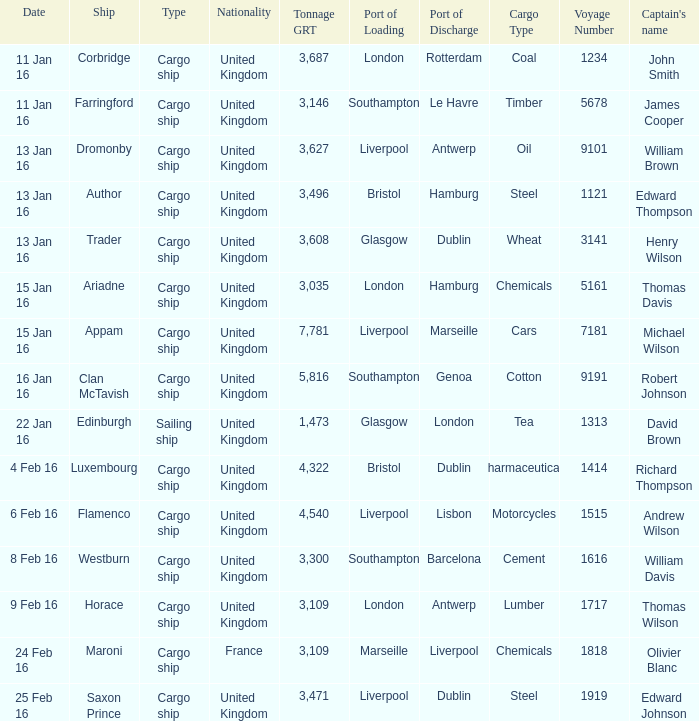What is the total tonnage grt of the cargo ship(s) sunk or captured on 4 feb 16? 1.0. 